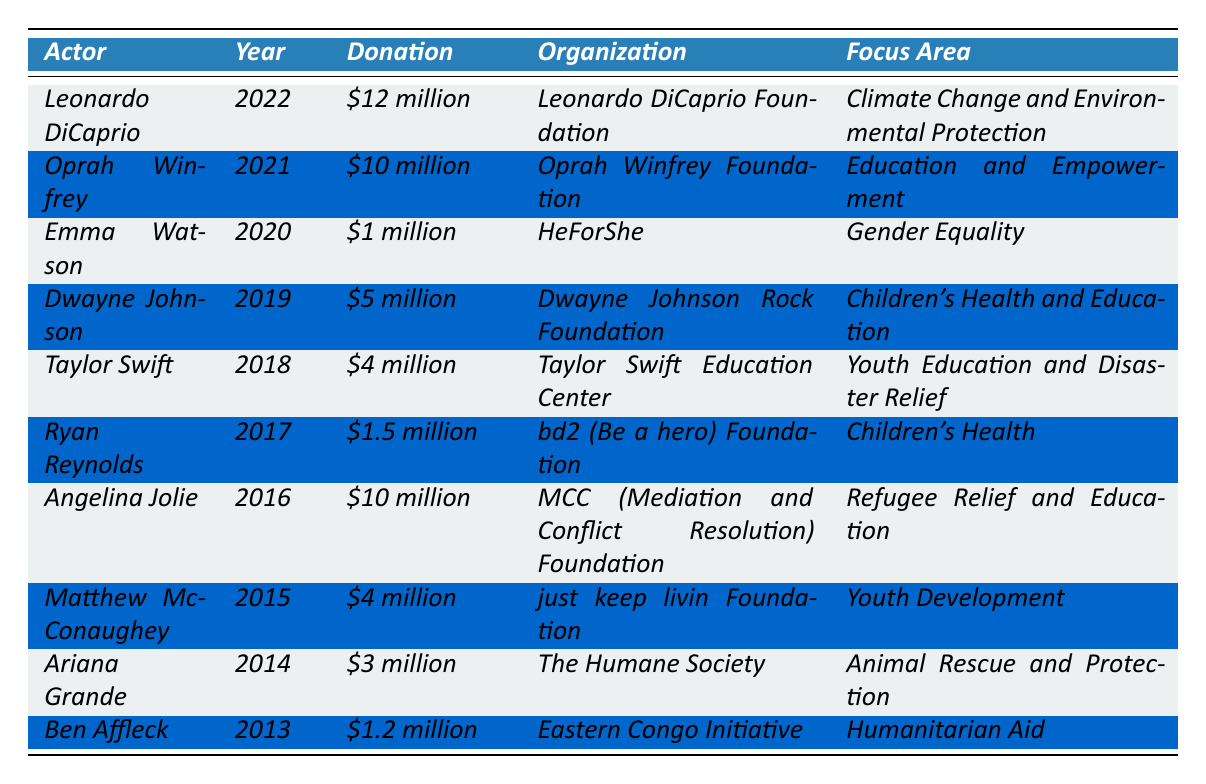What's the total amount donated by all actors in 2022? From the table, only Leonardo DiCaprio made a donation in 2022, which is $12 million.
Answer: $12 million Which organization received the largest donation? By examining the donations listed, Leonardo DiCaprio Foundation received $12 million, which is the highest amount compared to other organizations.
Answer: Leonardo DiCaprio Foundation Did any actor donate to a charity focusing on Gender Equality? Yes, Emma Watson donated $1 million to HeForShe, which focuses on Gender Equality.
Answer: Yes What is the average donation amount from all the actors listed in the table? The total donations are $12 million + $10 million + $1 million + $5 million + $4 million + $1.5 million + $10 million + $4 million + $3 million + $1.2 million = $52.7 million. There are 10 donations, so average = $52.7 million / 10 = $5.27 million.
Answer: $5.27 million Which actor donated the least amount, and what was the donation? Ben Affleck donated $1.2 million, which is less than any other actor listed in the table.
Answer: Ben Affleck, $1.2 million How many actors focused on children's health and education? From the table, Dwayne Johnson and Ryan Reynolds both have charities focusing on children's health and education, making a total of two actors.
Answer: 2 Was there a donation made towards Climate Change and Environmental Protection? Yes, Leonardo DiCaprio's donation in 2022 was directed towards that focus area.
Answer: Yes What year did Angelina Jolie make her donation and what was the amount? According to the table, Angelina Jolie made her $10 million donation in 2016.
Answer: 2016, $10 million How does Taylor Swift's donation compare to that of Dwayne Johnson's? Taylor Swift donated $4 million whereas Dwayne Johnson donated $5 million, meaning Dwayne Johnson's donation was $1 million higher.
Answer: Dwayne Johnson's donation was $1 million higher Are there any donations made from actors in the years 2014 to 2016? Yes, donations were made by Ariana Grande in 2014, Angelina Jolie in 2016, and Matthew McConaughey in 2015.
Answer: Yes What's the total amount donated for Youth Education and Disaster Relief? Taylor Swift donated $4 million for this focus area, which is the only entry in the table, so the total is $4 million.
Answer: $4 million 